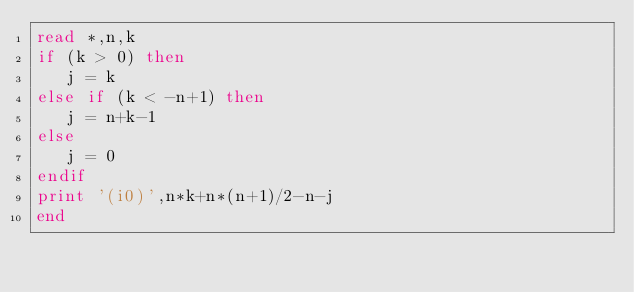<code> <loc_0><loc_0><loc_500><loc_500><_FORTRAN_>read *,n,k
if (k > 0) then
   j = k
else if (k < -n+1) then
   j = n+k-1
else
   j = 0
endif
print '(i0)',n*k+n*(n+1)/2-n-j
end</code> 